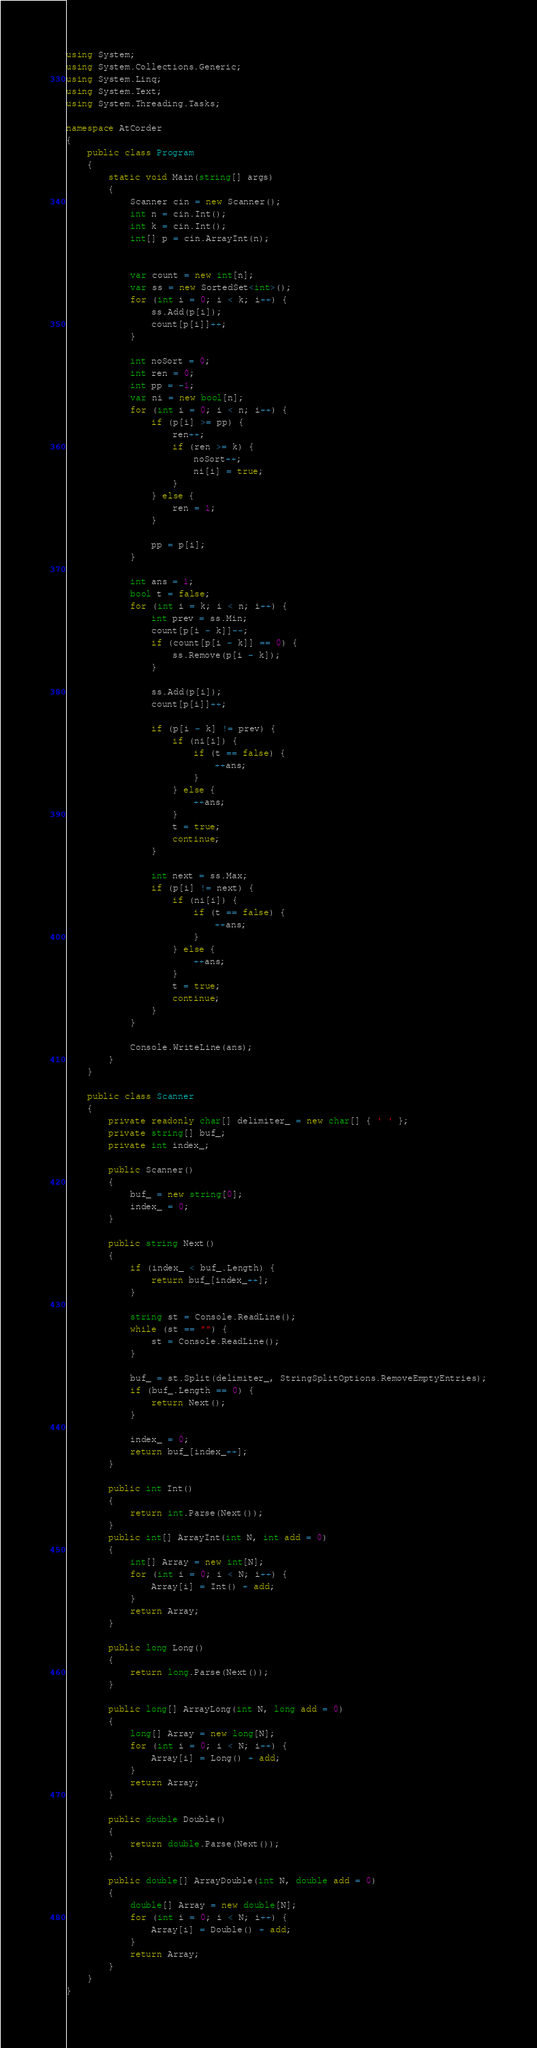<code> <loc_0><loc_0><loc_500><loc_500><_C#_>using System;
using System.Collections.Generic;
using System.Linq;
using System.Text;
using System.Threading.Tasks;

namespace AtCorder
{
	public class Program
	{
		static void Main(string[] args)
		{
			Scanner cin = new Scanner();
			int n = cin.Int();
			int k = cin.Int();
			int[] p = cin.ArrayInt(n);


			var count = new int[n];
			var ss = new SortedSet<int>();
			for (int i = 0; i < k; i++) {
				ss.Add(p[i]);
				count[p[i]]++;
			}

			int noSort = 0;
			int ren = 0;
			int pp = -1;
			var ni = new bool[n];
			for (int i = 0; i < n; i++) {
				if (p[i] >= pp) {
					ren++;
					if (ren >= k) {
						noSort++;
						ni[i] = true;
					}
				} else {
					ren = 1;
				}

				pp = p[i];
			}

			int ans = 1;
			bool t = false;
			for (int i = k; i < n; i++) {
				int prev = ss.Min;
				count[p[i - k]]--;
				if (count[p[i - k]] == 0) {
					ss.Remove(p[i - k]);
				}

				ss.Add(p[i]);
				count[p[i]]++;

				if (p[i - k] != prev) {
					if (ni[i]) {
						if (t == false) {
							++ans;
						}
					} else {
						++ans;
					}
					t = true;
					continue;
				}

				int next = ss.Max;
				if (p[i] != next) {
					if (ni[i]) {
						if (t == false) {
							++ans;
						}
					} else {
						++ans;
					}
					t = true;
					continue;
				}
			}

			Console.WriteLine(ans);
		}
	}

	public class Scanner
	{
		private readonly char[] delimiter_ = new char[] { ' ' };
		private string[] buf_;
		private int index_;

		public Scanner()
		{
			buf_ = new string[0];
			index_ = 0;
		}

		public string Next()
		{
			if (index_ < buf_.Length) {
				return buf_[index_++];
			}

			string st = Console.ReadLine();
			while (st == "") {
				st = Console.ReadLine();
			}

			buf_ = st.Split(delimiter_, StringSplitOptions.RemoveEmptyEntries);
			if (buf_.Length == 0) {
				return Next();
			}

			index_ = 0;
			return buf_[index_++];
		}

		public int Int()
		{
			return int.Parse(Next());
		}
		public int[] ArrayInt(int N, int add = 0)
		{
			int[] Array = new int[N];
			for (int i = 0; i < N; i++) {
				Array[i] = Int() + add;
			}
			return Array;
		}

		public long Long()
		{
			return long.Parse(Next());
		}

		public long[] ArrayLong(int N, long add = 0)
		{
			long[] Array = new long[N];
			for (int i = 0; i < N; i++) {
				Array[i] = Long() + add;
			}
			return Array;
		}

		public double Double()
		{
			return double.Parse(Next());
		}

		public double[] ArrayDouble(int N, double add = 0)
		{
			double[] Array = new double[N];
			for (int i = 0; i < N; i++) {
				Array[i] = Double() + add;
			}
			return Array;
		}
	}
}</code> 